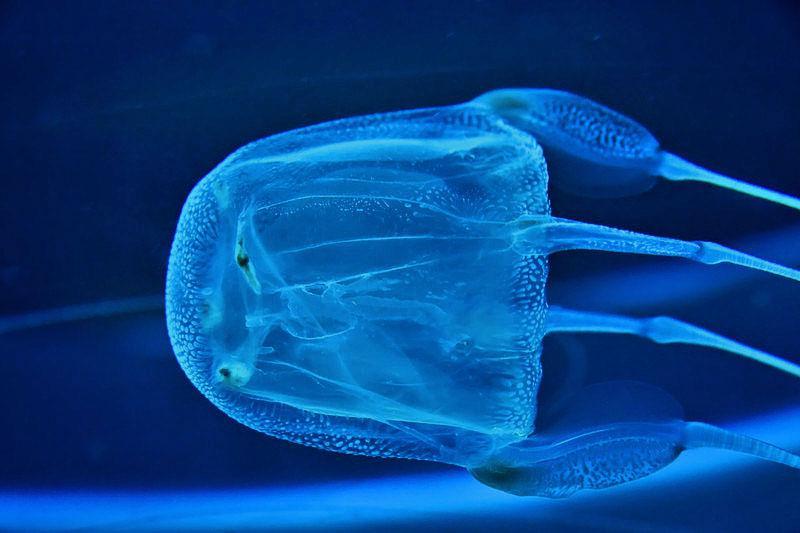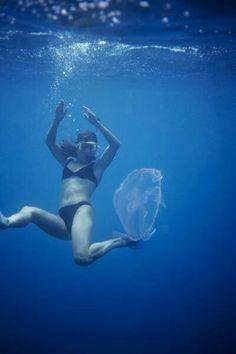The first image is the image on the left, the second image is the image on the right. Assess this claim about the two images: "There is a scuba diver with an airtank swimming with a jellyfish.". Correct or not? Answer yes or no. No. 